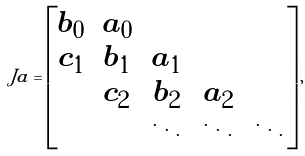<formula> <loc_0><loc_0><loc_500><loc_500>\ J a = \left [ \begin{matrix} b _ { 0 } & a _ { 0 } \\ c _ { 1 } & b _ { 1 } & a _ { 1 } \\ & c _ { 2 } & b _ { 2 } & a _ { 2 } \\ & & \ddots & \ddots & \ddots \end{matrix} \right ] ,</formula> 